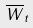<formula> <loc_0><loc_0><loc_500><loc_500>\overline { W } _ { t }</formula> 